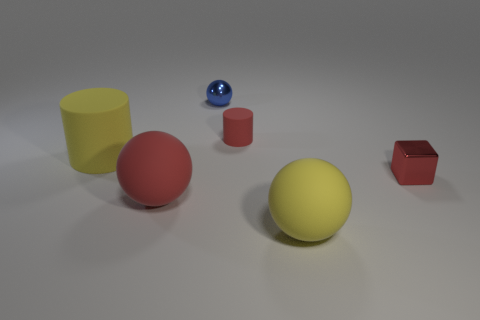What is the shape of the yellow thing on the right side of the yellow rubber object behind the red cube?
Your answer should be compact. Sphere. What is the color of the tiny thing that is made of the same material as the tiny red cube?
Your answer should be compact. Blue. Do the small rubber cylinder and the tiny shiny block have the same color?
Offer a terse response. Yes. What shape is the blue object that is the same size as the red block?
Your answer should be very brief. Sphere. The red block is what size?
Make the answer very short. Small. Does the red rubber object right of the red ball have the same size as the metal object that is behind the small block?
Provide a short and direct response. Yes. What is the color of the matte ball that is left of the metallic thing behind the small red rubber cylinder?
Make the answer very short. Red. There is a red cylinder that is the same size as the red metallic object; what is it made of?
Make the answer very short. Rubber. What number of metallic objects are either small purple cylinders or yellow cylinders?
Give a very brief answer. 0. What is the color of the rubber thing that is both behind the cube and on the left side of the small cylinder?
Provide a short and direct response. Yellow. 